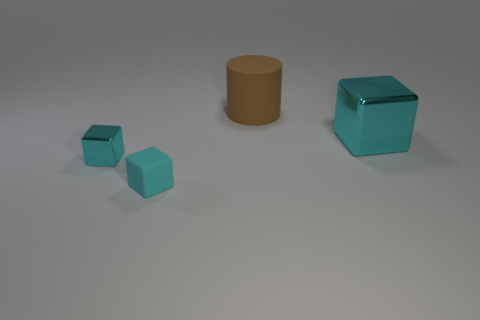What material is the cyan thing that is the same size as the brown matte cylinder?
Provide a succinct answer. Metal. Is the number of cyan metallic blocks behind the small cyan metallic thing less than the number of small cyan things that are to the right of the big shiny block?
Offer a very short reply. No. What is the shape of the thing that is both to the right of the cyan matte block and in front of the brown matte cylinder?
Offer a very short reply. Cube. What number of other objects are the same shape as the big shiny thing?
Ensure brevity in your answer.  2. What is the size of the cyan object that is the same material as the brown cylinder?
Your response must be concise. Small. Are there more small blue metallic blocks than big blocks?
Provide a short and direct response. No. What is the color of the thing that is to the right of the brown object?
Keep it short and to the point. Cyan. There is a object that is both behind the small cyan shiny block and in front of the brown cylinder; what is its size?
Your answer should be very brief. Large. What number of cyan shiny things are the same size as the brown cylinder?
Give a very brief answer. 1. What is the material of the big thing that is the same shape as the small cyan metallic thing?
Keep it short and to the point. Metal. 